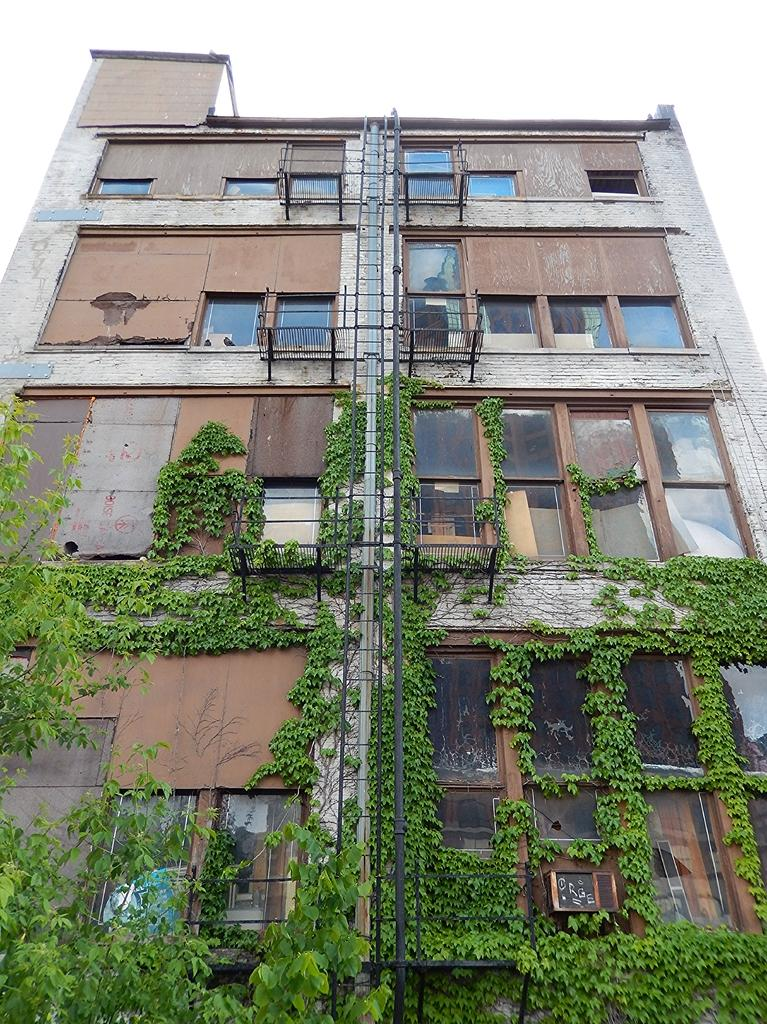What is the main subject in the center of the image? There is a building in the center of the image. What can be seen on the wall of the building? There are plants on the wall of the building. Where is the father and boy running in the image? There is no father or boy present in the image, nor is there any running. 